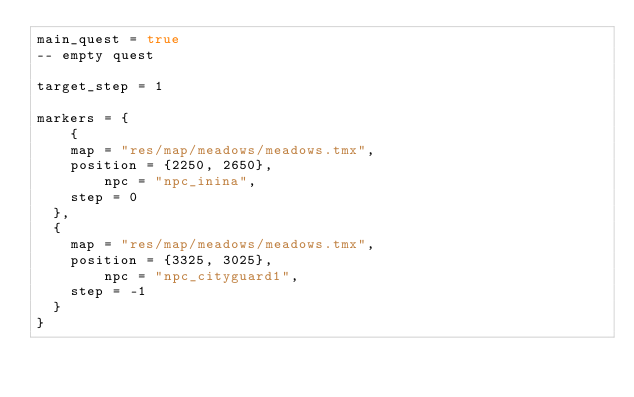Convert code to text. <code><loc_0><loc_0><loc_500><loc_500><_Lua_>main_quest = true
-- empty quest

target_step = 1

markers = {
    {
		map = "res/map/meadows/meadows.tmx",
		position = {2250, 2650},
        npc = "npc_inina",
		step = 0
	},
	{
		map = "res/map/meadows/meadows.tmx",
		position = {3325, 3025},
        npc = "npc_cityguard1",
		step = -1
	}
}</code> 